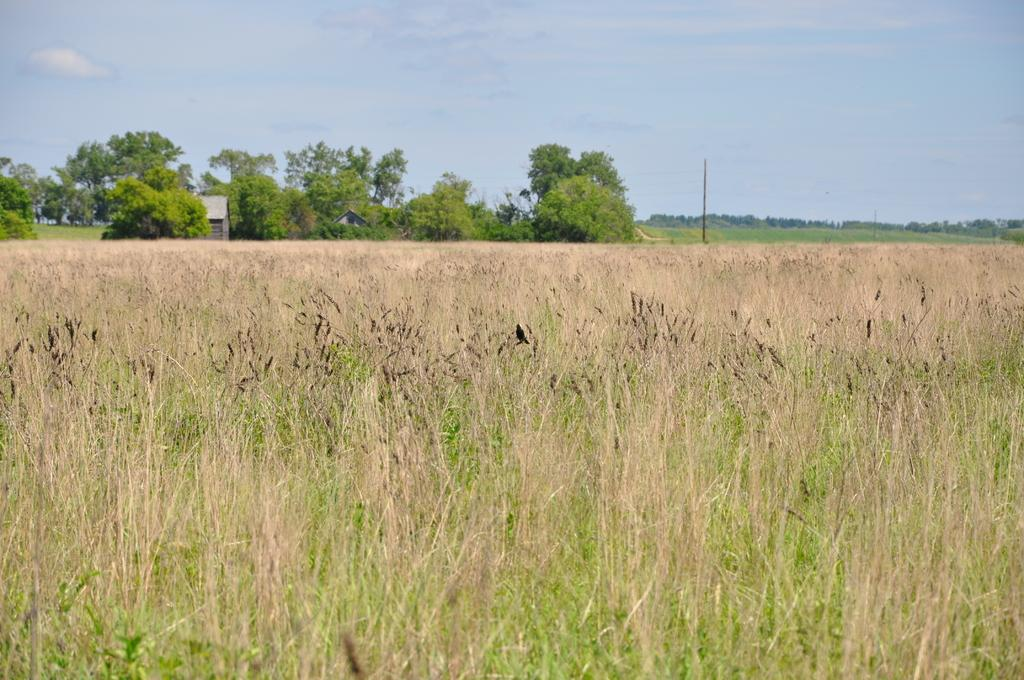What is located in the foreground of the image? There are plants in the foreground of the image. What can be seen in the background of the image? There are trees and a house in the background of the image. What other object is present in the background of the image? There is a pole in the background of the image. What is visible at the top of the image? The sky is visible at the top of the image. What type of comfort can be seen in the image? There is no specific comfort depicted in the image; it features plants, trees, a house, a pole, and the sky. How many bananas are visible in the image? There are no bananas present in the image. 